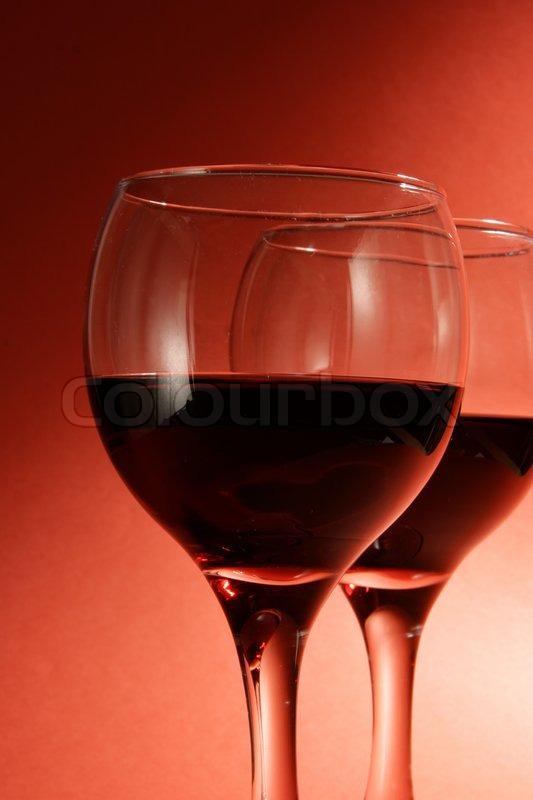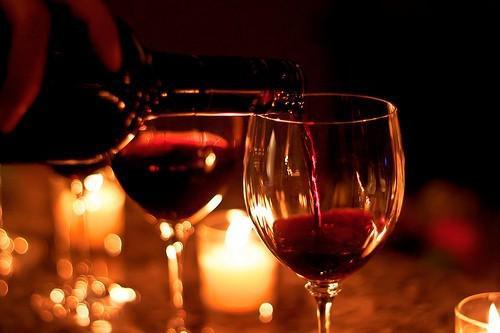The first image is the image on the left, the second image is the image on the right. Evaluate the accuracy of this statement regarding the images: "A hearth fire is visible in the background behind two glasses of dark red wine.". Is it true? Answer yes or no. No. 